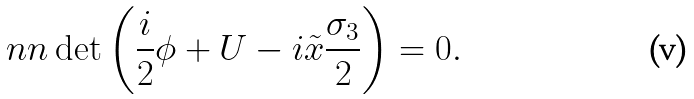Convert formula to latex. <formula><loc_0><loc_0><loc_500><loc_500>\ n n \det \left ( \frac { i } { 2 } \phi + U - i \tilde { x } \frac { \sigma _ { 3 } } { 2 } \right ) = 0 .</formula> 